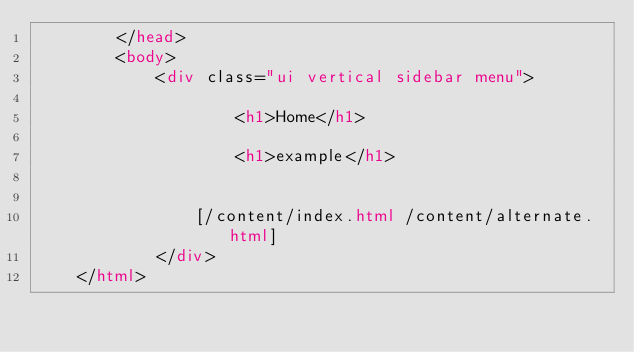<code> <loc_0><loc_0><loc_500><loc_500><_HTML_>        </head>
        <body>
            <div class="ui vertical sidebar menu">
                
                    <h1>Home</h1> 
                
                    <h1>example</h1> 
                

                [/content/index.html /content/alternate.html]
            </div>
    </html>
</code> 